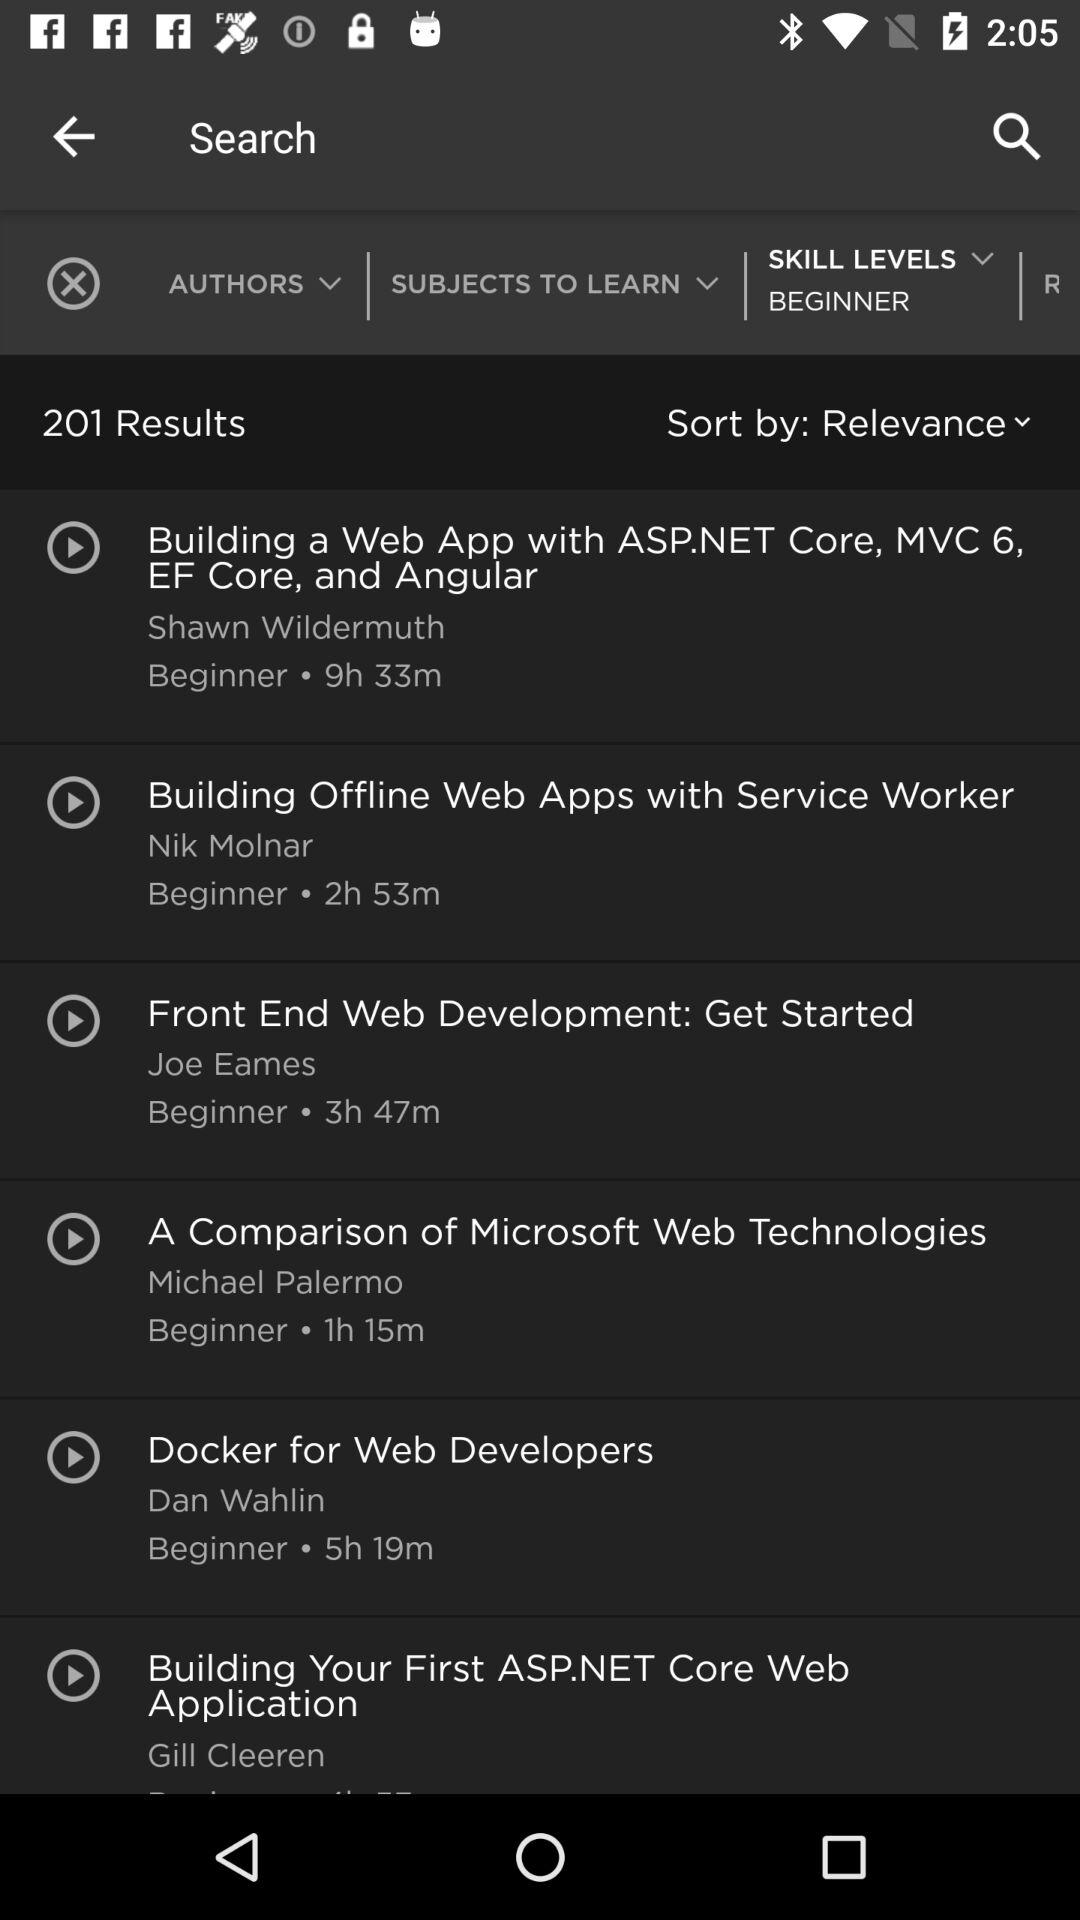Which category is selected as sort by? The selected category is "Relevance". 